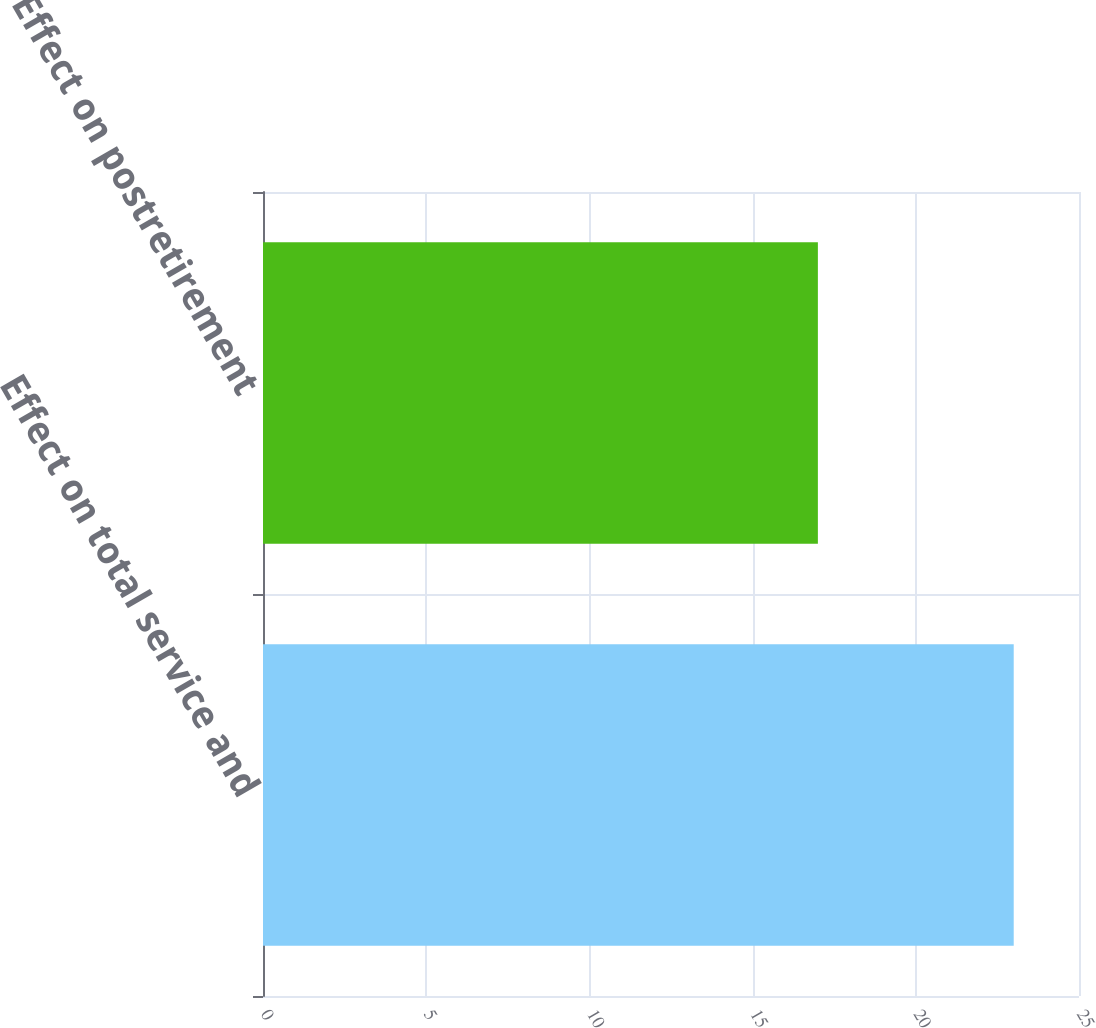Convert chart to OTSL. <chart><loc_0><loc_0><loc_500><loc_500><bar_chart><fcel>Effect on total service and<fcel>Effect on postretirement<nl><fcel>23<fcel>17<nl></chart> 